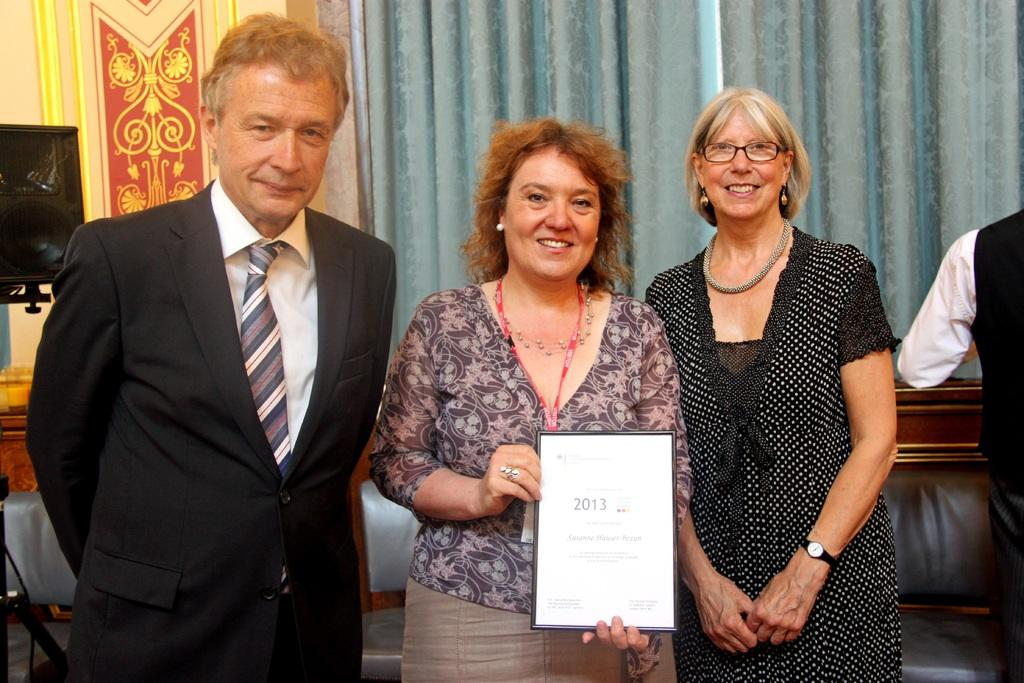What are the people in the image doing? The people in the image are standing. What is the woman holding in the image? The woman is holding a board. What type of window treatment is visible in the image? There are curtains visible in the image. What device is present for amplifying sound in the image? There is a speaker in the image. What type of ball is being used for digestion in the image? There is no ball or reference to digestion present in the image. 